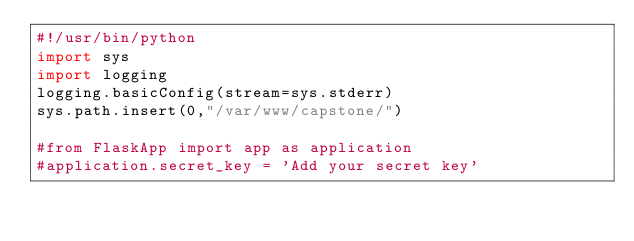<code> <loc_0><loc_0><loc_500><loc_500><_Python_>#!/usr/bin/python
import sys
import logging
logging.basicConfig(stream=sys.stderr)
sys.path.insert(0,"/var/www/capstone/")

#from FlaskApp import app as application
#application.secret_key = 'Add your secret key'
</code> 